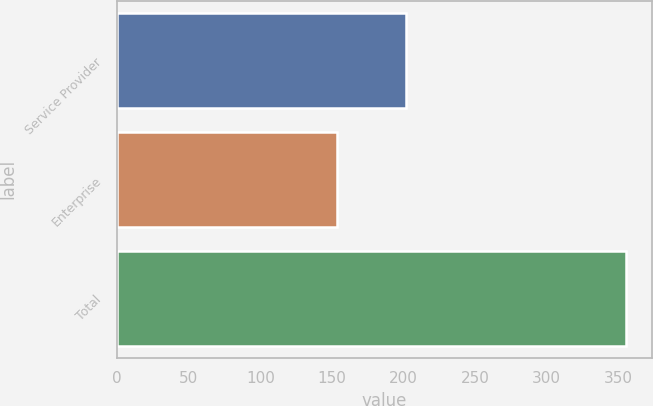Convert chart to OTSL. <chart><loc_0><loc_0><loc_500><loc_500><bar_chart><fcel>Service Provider<fcel>Enterprise<fcel>Total<nl><fcel>201.5<fcel>153.9<fcel>355.4<nl></chart> 